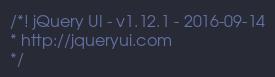<code> <loc_0><loc_0><loc_500><loc_500><_JavaScript_>/*! jQuery UI - v1.12.1 - 2016-09-14
* http://jqueryui.com
*/</code> 